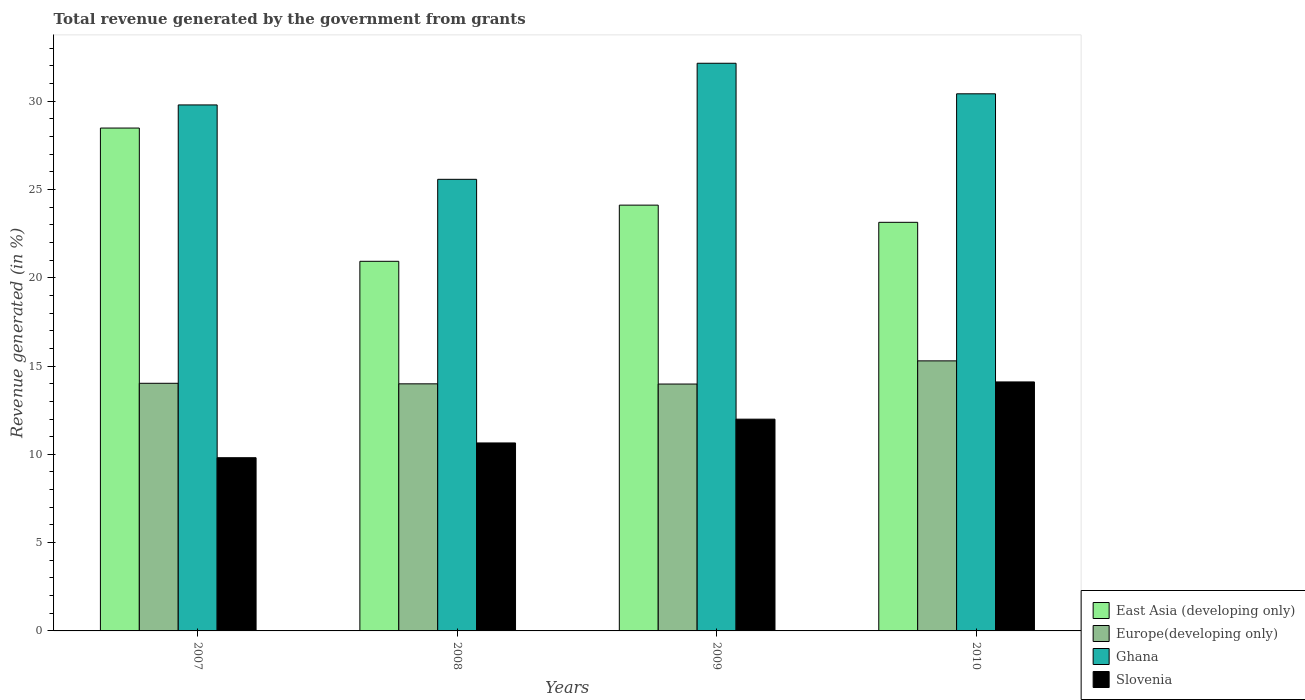Are the number of bars per tick equal to the number of legend labels?
Give a very brief answer. Yes. Are the number of bars on each tick of the X-axis equal?
Your response must be concise. Yes. How many bars are there on the 2nd tick from the right?
Your answer should be very brief. 4. In how many cases, is the number of bars for a given year not equal to the number of legend labels?
Provide a short and direct response. 0. What is the total revenue generated in Slovenia in 2010?
Give a very brief answer. 14.1. Across all years, what is the maximum total revenue generated in East Asia (developing only)?
Provide a succinct answer. 28.48. Across all years, what is the minimum total revenue generated in East Asia (developing only)?
Offer a terse response. 20.93. In which year was the total revenue generated in Slovenia minimum?
Offer a very short reply. 2007. What is the total total revenue generated in Slovenia in the graph?
Give a very brief answer. 46.55. What is the difference between the total revenue generated in Slovenia in 2008 and that in 2009?
Offer a very short reply. -1.35. What is the difference between the total revenue generated in East Asia (developing only) in 2007 and the total revenue generated in Ghana in 2008?
Make the answer very short. 2.9. What is the average total revenue generated in Slovenia per year?
Provide a short and direct response. 11.64. In the year 2007, what is the difference between the total revenue generated in Ghana and total revenue generated in Europe(developing only)?
Your answer should be compact. 15.76. In how many years, is the total revenue generated in Ghana greater than 22 %?
Provide a short and direct response. 4. What is the ratio of the total revenue generated in Europe(developing only) in 2009 to that in 2010?
Give a very brief answer. 0.91. Is the difference between the total revenue generated in Ghana in 2007 and 2008 greater than the difference between the total revenue generated in Europe(developing only) in 2007 and 2008?
Give a very brief answer. Yes. What is the difference between the highest and the second highest total revenue generated in Slovenia?
Keep it short and to the point. 2.11. What is the difference between the highest and the lowest total revenue generated in Europe(developing only)?
Provide a short and direct response. 1.31. Is the sum of the total revenue generated in Slovenia in 2007 and 2008 greater than the maximum total revenue generated in Europe(developing only) across all years?
Provide a succinct answer. Yes. What does the 1st bar from the left in 2010 represents?
Ensure brevity in your answer.  East Asia (developing only). What does the 1st bar from the right in 2007 represents?
Keep it short and to the point. Slovenia. Is it the case that in every year, the sum of the total revenue generated in East Asia (developing only) and total revenue generated in Europe(developing only) is greater than the total revenue generated in Ghana?
Provide a succinct answer. Yes. How many bars are there?
Your answer should be very brief. 16. Are all the bars in the graph horizontal?
Your response must be concise. No. Are the values on the major ticks of Y-axis written in scientific E-notation?
Your answer should be compact. No. Does the graph contain grids?
Provide a short and direct response. No. What is the title of the graph?
Make the answer very short. Total revenue generated by the government from grants. What is the label or title of the Y-axis?
Provide a short and direct response. Revenue generated (in %). What is the Revenue generated (in %) of East Asia (developing only) in 2007?
Provide a succinct answer. 28.48. What is the Revenue generated (in %) in Europe(developing only) in 2007?
Your answer should be compact. 14.02. What is the Revenue generated (in %) in Ghana in 2007?
Your answer should be compact. 29.79. What is the Revenue generated (in %) in Slovenia in 2007?
Your response must be concise. 9.81. What is the Revenue generated (in %) of East Asia (developing only) in 2008?
Provide a succinct answer. 20.93. What is the Revenue generated (in %) in Europe(developing only) in 2008?
Keep it short and to the point. 13.99. What is the Revenue generated (in %) in Ghana in 2008?
Make the answer very short. 25.57. What is the Revenue generated (in %) of Slovenia in 2008?
Make the answer very short. 10.64. What is the Revenue generated (in %) of East Asia (developing only) in 2009?
Your response must be concise. 24.11. What is the Revenue generated (in %) in Europe(developing only) in 2009?
Provide a succinct answer. 13.98. What is the Revenue generated (in %) of Ghana in 2009?
Give a very brief answer. 32.15. What is the Revenue generated (in %) in Slovenia in 2009?
Provide a succinct answer. 11.99. What is the Revenue generated (in %) in East Asia (developing only) in 2010?
Provide a short and direct response. 23.14. What is the Revenue generated (in %) of Europe(developing only) in 2010?
Provide a short and direct response. 15.29. What is the Revenue generated (in %) of Ghana in 2010?
Give a very brief answer. 30.42. What is the Revenue generated (in %) in Slovenia in 2010?
Ensure brevity in your answer.  14.1. Across all years, what is the maximum Revenue generated (in %) in East Asia (developing only)?
Provide a short and direct response. 28.48. Across all years, what is the maximum Revenue generated (in %) of Europe(developing only)?
Give a very brief answer. 15.29. Across all years, what is the maximum Revenue generated (in %) in Ghana?
Provide a short and direct response. 32.15. Across all years, what is the maximum Revenue generated (in %) of Slovenia?
Your answer should be very brief. 14.1. Across all years, what is the minimum Revenue generated (in %) of East Asia (developing only)?
Keep it short and to the point. 20.93. Across all years, what is the minimum Revenue generated (in %) in Europe(developing only)?
Offer a very short reply. 13.98. Across all years, what is the minimum Revenue generated (in %) of Ghana?
Your response must be concise. 25.57. Across all years, what is the minimum Revenue generated (in %) of Slovenia?
Ensure brevity in your answer.  9.81. What is the total Revenue generated (in %) of East Asia (developing only) in the graph?
Provide a succinct answer. 96.66. What is the total Revenue generated (in %) of Europe(developing only) in the graph?
Provide a succinct answer. 57.29. What is the total Revenue generated (in %) of Ghana in the graph?
Keep it short and to the point. 117.92. What is the total Revenue generated (in %) of Slovenia in the graph?
Ensure brevity in your answer.  46.55. What is the difference between the Revenue generated (in %) in East Asia (developing only) in 2007 and that in 2008?
Give a very brief answer. 7.55. What is the difference between the Revenue generated (in %) of Europe(developing only) in 2007 and that in 2008?
Your response must be concise. 0.03. What is the difference between the Revenue generated (in %) in Ghana in 2007 and that in 2008?
Keep it short and to the point. 4.21. What is the difference between the Revenue generated (in %) in Slovenia in 2007 and that in 2008?
Provide a short and direct response. -0.84. What is the difference between the Revenue generated (in %) of East Asia (developing only) in 2007 and that in 2009?
Offer a terse response. 4.37. What is the difference between the Revenue generated (in %) in Europe(developing only) in 2007 and that in 2009?
Keep it short and to the point. 0.04. What is the difference between the Revenue generated (in %) of Ghana in 2007 and that in 2009?
Offer a very short reply. -2.36. What is the difference between the Revenue generated (in %) of Slovenia in 2007 and that in 2009?
Give a very brief answer. -2.18. What is the difference between the Revenue generated (in %) in East Asia (developing only) in 2007 and that in 2010?
Your response must be concise. 5.34. What is the difference between the Revenue generated (in %) of Europe(developing only) in 2007 and that in 2010?
Offer a very short reply. -1.27. What is the difference between the Revenue generated (in %) of Ghana in 2007 and that in 2010?
Provide a succinct answer. -0.63. What is the difference between the Revenue generated (in %) in Slovenia in 2007 and that in 2010?
Provide a short and direct response. -4.29. What is the difference between the Revenue generated (in %) of East Asia (developing only) in 2008 and that in 2009?
Provide a short and direct response. -3.18. What is the difference between the Revenue generated (in %) in Europe(developing only) in 2008 and that in 2009?
Make the answer very short. 0.01. What is the difference between the Revenue generated (in %) of Ghana in 2008 and that in 2009?
Give a very brief answer. -6.57. What is the difference between the Revenue generated (in %) of Slovenia in 2008 and that in 2009?
Keep it short and to the point. -1.35. What is the difference between the Revenue generated (in %) of East Asia (developing only) in 2008 and that in 2010?
Your answer should be very brief. -2.21. What is the difference between the Revenue generated (in %) of Europe(developing only) in 2008 and that in 2010?
Give a very brief answer. -1.3. What is the difference between the Revenue generated (in %) in Ghana in 2008 and that in 2010?
Provide a succinct answer. -4.84. What is the difference between the Revenue generated (in %) in Slovenia in 2008 and that in 2010?
Keep it short and to the point. -3.46. What is the difference between the Revenue generated (in %) of East Asia (developing only) in 2009 and that in 2010?
Your answer should be compact. 0.97. What is the difference between the Revenue generated (in %) of Europe(developing only) in 2009 and that in 2010?
Provide a short and direct response. -1.31. What is the difference between the Revenue generated (in %) in Ghana in 2009 and that in 2010?
Your response must be concise. 1.73. What is the difference between the Revenue generated (in %) in Slovenia in 2009 and that in 2010?
Provide a succinct answer. -2.11. What is the difference between the Revenue generated (in %) of East Asia (developing only) in 2007 and the Revenue generated (in %) of Europe(developing only) in 2008?
Your answer should be compact. 14.49. What is the difference between the Revenue generated (in %) of East Asia (developing only) in 2007 and the Revenue generated (in %) of Ghana in 2008?
Provide a short and direct response. 2.9. What is the difference between the Revenue generated (in %) in East Asia (developing only) in 2007 and the Revenue generated (in %) in Slovenia in 2008?
Keep it short and to the point. 17.83. What is the difference between the Revenue generated (in %) in Europe(developing only) in 2007 and the Revenue generated (in %) in Ghana in 2008?
Provide a succinct answer. -11.55. What is the difference between the Revenue generated (in %) in Europe(developing only) in 2007 and the Revenue generated (in %) in Slovenia in 2008?
Your answer should be compact. 3.38. What is the difference between the Revenue generated (in %) in Ghana in 2007 and the Revenue generated (in %) in Slovenia in 2008?
Offer a very short reply. 19.14. What is the difference between the Revenue generated (in %) in East Asia (developing only) in 2007 and the Revenue generated (in %) in Europe(developing only) in 2009?
Your response must be concise. 14.5. What is the difference between the Revenue generated (in %) in East Asia (developing only) in 2007 and the Revenue generated (in %) in Ghana in 2009?
Give a very brief answer. -3.67. What is the difference between the Revenue generated (in %) of East Asia (developing only) in 2007 and the Revenue generated (in %) of Slovenia in 2009?
Provide a succinct answer. 16.49. What is the difference between the Revenue generated (in %) of Europe(developing only) in 2007 and the Revenue generated (in %) of Ghana in 2009?
Your answer should be compact. -18.12. What is the difference between the Revenue generated (in %) of Europe(developing only) in 2007 and the Revenue generated (in %) of Slovenia in 2009?
Give a very brief answer. 2.03. What is the difference between the Revenue generated (in %) of Ghana in 2007 and the Revenue generated (in %) of Slovenia in 2009?
Keep it short and to the point. 17.8. What is the difference between the Revenue generated (in %) in East Asia (developing only) in 2007 and the Revenue generated (in %) in Europe(developing only) in 2010?
Give a very brief answer. 13.18. What is the difference between the Revenue generated (in %) of East Asia (developing only) in 2007 and the Revenue generated (in %) of Ghana in 2010?
Offer a very short reply. -1.94. What is the difference between the Revenue generated (in %) of East Asia (developing only) in 2007 and the Revenue generated (in %) of Slovenia in 2010?
Provide a short and direct response. 14.38. What is the difference between the Revenue generated (in %) in Europe(developing only) in 2007 and the Revenue generated (in %) in Ghana in 2010?
Ensure brevity in your answer.  -16.39. What is the difference between the Revenue generated (in %) in Europe(developing only) in 2007 and the Revenue generated (in %) in Slovenia in 2010?
Provide a succinct answer. -0.08. What is the difference between the Revenue generated (in %) of Ghana in 2007 and the Revenue generated (in %) of Slovenia in 2010?
Make the answer very short. 15.69. What is the difference between the Revenue generated (in %) in East Asia (developing only) in 2008 and the Revenue generated (in %) in Europe(developing only) in 2009?
Your response must be concise. 6.95. What is the difference between the Revenue generated (in %) of East Asia (developing only) in 2008 and the Revenue generated (in %) of Ghana in 2009?
Make the answer very short. -11.22. What is the difference between the Revenue generated (in %) in East Asia (developing only) in 2008 and the Revenue generated (in %) in Slovenia in 2009?
Make the answer very short. 8.94. What is the difference between the Revenue generated (in %) of Europe(developing only) in 2008 and the Revenue generated (in %) of Ghana in 2009?
Provide a succinct answer. -18.15. What is the difference between the Revenue generated (in %) in Europe(developing only) in 2008 and the Revenue generated (in %) in Slovenia in 2009?
Offer a very short reply. 2. What is the difference between the Revenue generated (in %) of Ghana in 2008 and the Revenue generated (in %) of Slovenia in 2009?
Provide a short and direct response. 13.58. What is the difference between the Revenue generated (in %) of East Asia (developing only) in 2008 and the Revenue generated (in %) of Europe(developing only) in 2010?
Your answer should be compact. 5.64. What is the difference between the Revenue generated (in %) in East Asia (developing only) in 2008 and the Revenue generated (in %) in Ghana in 2010?
Your response must be concise. -9.49. What is the difference between the Revenue generated (in %) in East Asia (developing only) in 2008 and the Revenue generated (in %) in Slovenia in 2010?
Make the answer very short. 6.83. What is the difference between the Revenue generated (in %) in Europe(developing only) in 2008 and the Revenue generated (in %) in Ghana in 2010?
Your answer should be very brief. -16.42. What is the difference between the Revenue generated (in %) in Europe(developing only) in 2008 and the Revenue generated (in %) in Slovenia in 2010?
Keep it short and to the point. -0.11. What is the difference between the Revenue generated (in %) of Ghana in 2008 and the Revenue generated (in %) of Slovenia in 2010?
Offer a terse response. 11.47. What is the difference between the Revenue generated (in %) of East Asia (developing only) in 2009 and the Revenue generated (in %) of Europe(developing only) in 2010?
Provide a succinct answer. 8.82. What is the difference between the Revenue generated (in %) of East Asia (developing only) in 2009 and the Revenue generated (in %) of Ghana in 2010?
Keep it short and to the point. -6.3. What is the difference between the Revenue generated (in %) of East Asia (developing only) in 2009 and the Revenue generated (in %) of Slovenia in 2010?
Offer a very short reply. 10.01. What is the difference between the Revenue generated (in %) in Europe(developing only) in 2009 and the Revenue generated (in %) in Ghana in 2010?
Make the answer very short. -16.44. What is the difference between the Revenue generated (in %) of Europe(developing only) in 2009 and the Revenue generated (in %) of Slovenia in 2010?
Your answer should be compact. -0.12. What is the difference between the Revenue generated (in %) in Ghana in 2009 and the Revenue generated (in %) in Slovenia in 2010?
Offer a very short reply. 18.05. What is the average Revenue generated (in %) in East Asia (developing only) per year?
Keep it short and to the point. 24.16. What is the average Revenue generated (in %) in Europe(developing only) per year?
Provide a succinct answer. 14.32. What is the average Revenue generated (in %) of Ghana per year?
Offer a terse response. 29.48. What is the average Revenue generated (in %) of Slovenia per year?
Offer a terse response. 11.64. In the year 2007, what is the difference between the Revenue generated (in %) in East Asia (developing only) and Revenue generated (in %) in Europe(developing only)?
Give a very brief answer. 14.45. In the year 2007, what is the difference between the Revenue generated (in %) of East Asia (developing only) and Revenue generated (in %) of Ghana?
Give a very brief answer. -1.31. In the year 2007, what is the difference between the Revenue generated (in %) of East Asia (developing only) and Revenue generated (in %) of Slovenia?
Offer a very short reply. 18.67. In the year 2007, what is the difference between the Revenue generated (in %) of Europe(developing only) and Revenue generated (in %) of Ghana?
Offer a terse response. -15.76. In the year 2007, what is the difference between the Revenue generated (in %) of Europe(developing only) and Revenue generated (in %) of Slovenia?
Provide a succinct answer. 4.21. In the year 2007, what is the difference between the Revenue generated (in %) in Ghana and Revenue generated (in %) in Slovenia?
Offer a very short reply. 19.98. In the year 2008, what is the difference between the Revenue generated (in %) of East Asia (developing only) and Revenue generated (in %) of Europe(developing only)?
Offer a terse response. 6.94. In the year 2008, what is the difference between the Revenue generated (in %) in East Asia (developing only) and Revenue generated (in %) in Ghana?
Ensure brevity in your answer.  -4.64. In the year 2008, what is the difference between the Revenue generated (in %) in East Asia (developing only) and Revenue generated (in %) in Slovenia?
Make the answer very short. 10.29. In the year 2008, what is the difference between the Revenue generated (in %) in Europe(developing only) and Revenue generated (in %) in Ghana?
Provide a succinct answer. -11.58. In the year 2008, what is the difference between the Revenue generated (in %) in Europe(developing only) and Revenue generated (in %) in Slovenia?
Give a very brief answer. 3.35. In the year 2008, what is the difference between the Revenue generated (in %) of Ghana and Revenue generated (in %) of Slovenia?
Your answer should be compact. 14.93. In the year 2009, what is the difference between the Revenue generated (in %) in East Asia (developing only) and Revenue generated (in %) in Europe(developing only)?
Ensure brevity in your answer.  10.13. In the year 2009, what is the difference between the Revenue generated (in %) in East Asia (developing only) and Revenue generated (in %) in Ghana?
Your response must be concise. -8.03. In the year 2009, what is the difference between the Revenue generated (in %) in East Asia (developing only) and Revenue generated (in %) in Slovenia?
Offer a very short reply. 12.12. In the year 2009, what is the difference between the Revenue generated (in %) of Europe(developing only) and Revenue generated (in %) of Ghana?
Keep it short and to the point. -18.17. In the year 2009, what is the difference between the Revenue generated (in %) of Europe(developing only) and Revenue generated (in %) of Slovenia?
Provide a succinct answer. 1.99. In the year 2009, what is the difference between the Revenue generated (in %) of Ghana and Revenue generated (in %) of Slovenia?
Your answer should be compact. 20.16. In the year 2010, what is the difference between the Revenue generated (in %) of East Asia (developing only) and Revenue generated (in %) of Europe(developing only)?
Keep it short and to the point. 7.85. In the year 2010, what is the difference between the Revenue generated (in %) of East Asia (developing only) and Revenue generated (in %) of Ghana?
Provide a succinct answer. -7.28. In the year 2010, what is the difference between the Revenue generated (in %) in East Asia (developing only) and Revenue generated (in %) in Slovenia?
Your response must be concise. 9.04. In the year 2010, what is the difference between the Revenue generated (in %) of Europe(developing only) and Revenue generated (in %) of Ghana?
Offer a terse response. -15.12. In the year 2010, what is the difference between the Revenue generated (in %) in Europe(developing only) and Revenue generated (in %) in Slovenia?
Keep it short and to the point. 1.19. In the year 2010, what is the difference between the Revenue generated (in %) in Ghana and Revenue generated (in %) in Slovenia?
Your response must be concise. 16.32. What is the ratio of the Revenue generated (in %) in East Asia (developing only) in 2007 to that in 2008?
Offer a very short reply. 1.36. What is the ratio of the Revenue generated (in %) in Europe(developing only) in 2007 to that in 2008?
Give a very brief answer. 1. What is the ratio of the Revenue generated (in %) in Ghana in 2007 to that in 2008?
Offer a terse response. 1.16. What is the ratio of the Revenue generated (in %) in Slovenia in 2007 to that in 2008?
Your response must be concise. 0.92. What is the ratio of the Revenue generated (in %) in East Asia (developing only) in 2007 to that in 2009?
Your answer should be very brief. 1.18. What is the ratio of the Revenue generated (in %) of Ghana in 2007 to that in 2009?
Provide a succinct answer. 0.93. What is the ratio of the Revenue generated (in %) of Slovenia in 2007 to that in 2009?
Your answer should be compact. 0.82. What is the ratio of the Revenue generated (in %) in East Asia (developing only) in 2007 to that in 2010?
Offer a very short reply. 1.23. What is the ratio of the Revenue generated (in %) in Europe(developing only) in 2007 to that in 2010?
Offer a terse response. 0.92. What is the ratio of the Revenue generated (in %) in Ghana in 2007 to that in 2010?
Give a very brief answer. 0.98. What is the ratio of the Revenue generated (in %) in Slovenia in 2007 to that in 2010?
Offer a terse response. 0.7. What is the ratio of the Revenue generated (in %) in East Asia (developing only) in 2008 to that in 2009?
Your answer should be compact. 0.87. What is the ratio of the Revenue generated (in %) of Europe(developing only) in 2008 to that in 2009?
Your answer should be very brief. 1. What is the ratio of the Revenue generated (in %) in Ghana in 2008 to that in 2009?
Keep it short and to the point. 0.8. What is the ratio of the Revenue generated (in %) in Slovenia in 2008 to that in 2009?
Your answer should be very brief. 0.89. What is the ratio of the Revenue generated (in %) in East Asia (developing only) in 2008 to that in 2010?
Offer a very short reply. 0.9. What is the ratio of the Revenue generated (in %) of Europe(developing only) in 2008 to that in 2010?
Provide a succinct answer. 0.91. What is the ratio of the Revenue generated (in %) of Ghana in 2008 to that in 2010?
Your answer should be very brief. 0.84. What is the ratio of the Revenue generated (in %) of Slovenia in 2008 to that in 2010?
Ensure brevity in your answer.  0.75. What is the ratio of the Revenue generated (in %) of East Asia (developing only) in 2009 to that in 2010?
Your response must be concise. 1.04. What is the ratio of the Revenue generated (in %) of Europe(developing only) in 2009 to that in 2010?
Offer a very short reply. 0.91. What is the ratio of the Revenue generated (in %) in Ghana in 2009 to that in 2010?
Ensure brevity in your answer.  1.06. What is the ratio of the Revenue generated (in %) in Slovenia in 2009 to that in 2010?
Make the answer very short. 0.85. What is the difference between the highest and the second highest Revenue generated (in %) of East Asia (developing only)?
Your answer should be compact. 4.37. What is the difference between the highest and the second highest Revenue generated (in %) in Europe(developing only)?
Ensure brevity in your answer.  1.27. What is the difference between the highest and the second highest Revenue generated (in %) in Ghana?
Your response must be concise. 1.73. What is the difference between the highest and the second highest Revenue generated (in %) in Slovenia?
Give a very brief answer. 2.11. What is the difference between the highest and the lowest Revenue generated (in %) of East Asia (developing only)?
Offer a terse response. 7.55. What is the difference between the highest and the lowest Revenue generated (in %) in Europe(developing only)?
Make the answer very short. 1.31. What is the difference between the highest and the lowest Revenue generated (in %) of Ghana?
Give a very brief answer. 6.57. What is the difference between the highest and the lowest Revenue generated (in %) in Slovenia?
Ensure brevity in your answer.  4.29. 